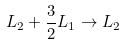Convert formula to latex. <formula><loc_0><loc_0><loc_500><loc_500>L _ { 2 } + \frac { 3 } { 2 } L _ { 1 } \rightarrow L _ { 2 }</formula> 